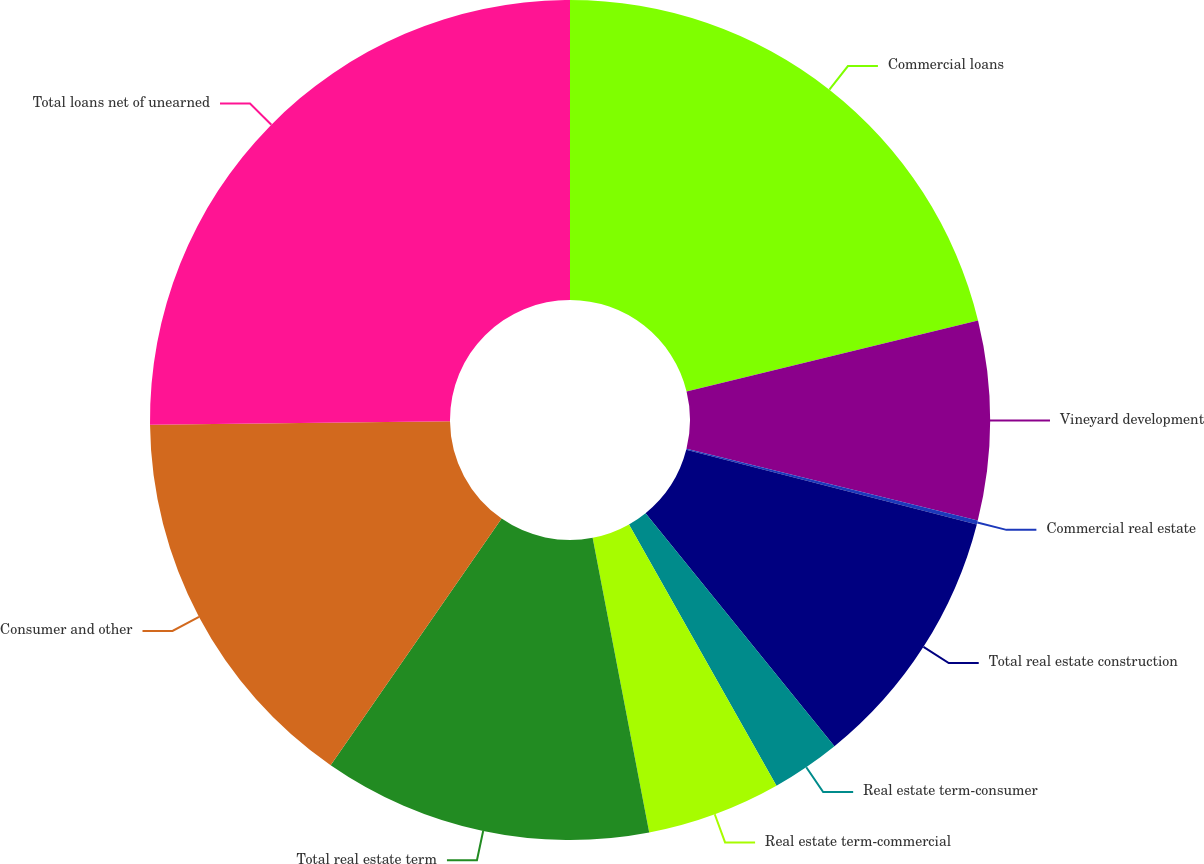Convert chart. <chart><loc_0><loc_0><loc_500><loc_500><pie_chart><fcel>Commercial loans<fcel>Vineyard development<fcel>Commercial real estate<fcel>Total real estate construction<fcel>Real estate term-consumer<fcel>Real estate term-commercial<fcel>Total real estate term<fcel>Consumer and other<fcel>Total loans net of unearned<nl><fcel>21.19%<fcel>7.66%<fcel>0.15%<fcel>10.16%<fcel>2.66%<fcel>5.16%<fcel>12.67%<fcel>15.17%<fcel>25.18%<nl></chart> 